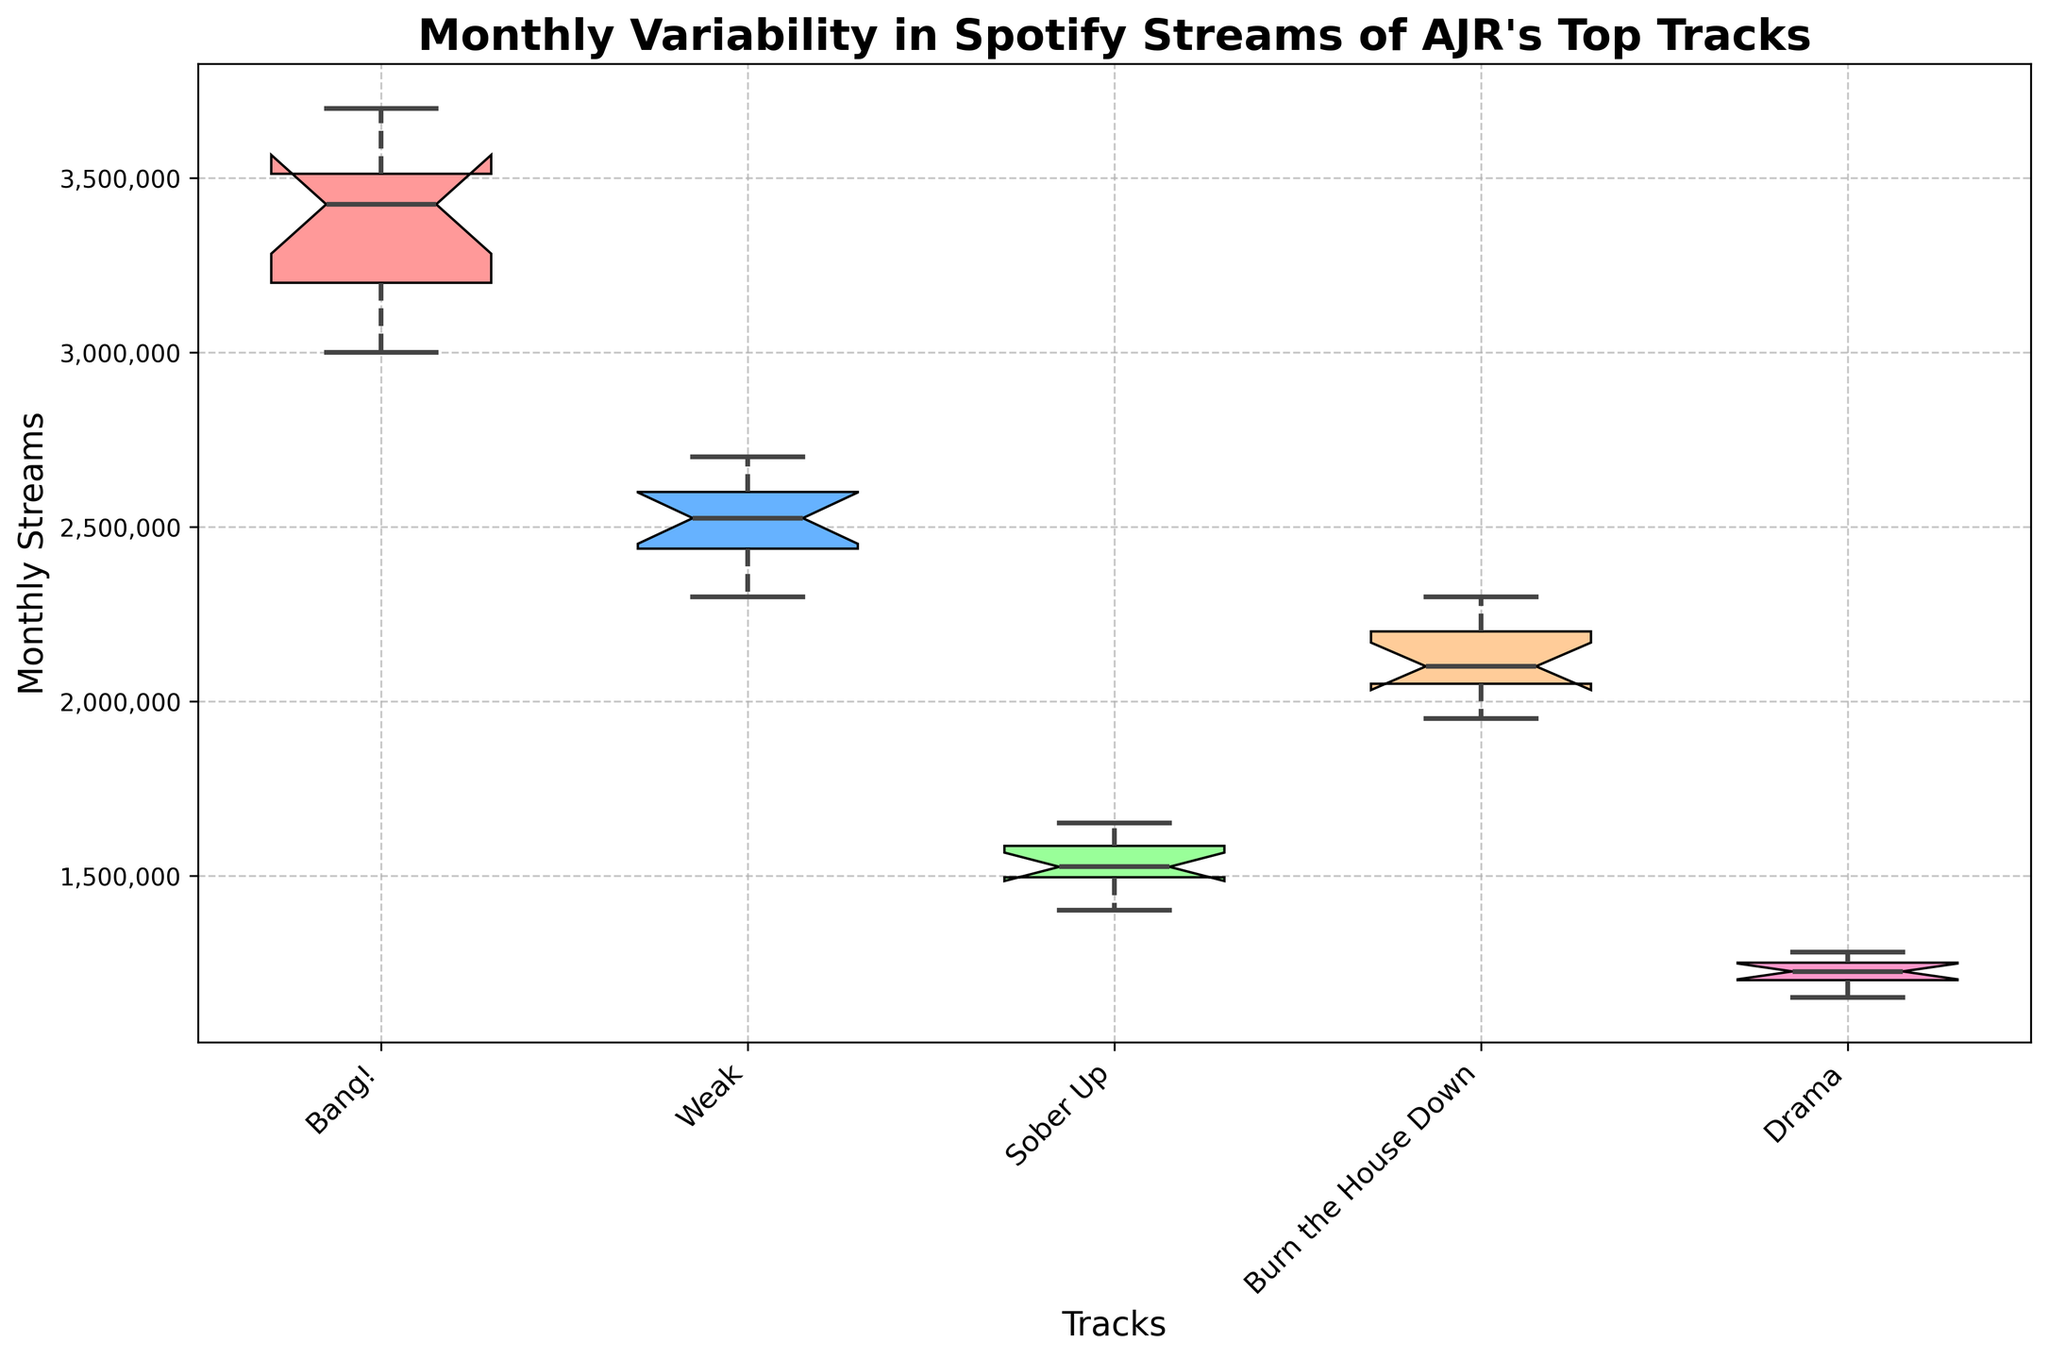What is the title of the plot? The title is located at the top of the plot.
Answer: Monthly Variability in Spotify Streams of AJR's Top Tracks How many tracks are represented in the notched box plot? The x-axis labels list the tracks. Count the unique labels.
Answer: 5 Which track has the highest median monthly streams? Identify the median (middle line) of each track's box plot. Look for the highest median line.
Answer: Bang! Which track shows the least variability in monthly streams? Variability is indicated by the width of the box and the length of the whiskers. The track with the smallest box and shortest whiskers has the least variability.
Answer: Drama Are there any outliers in the data? If yes, for which tracks? Outliers are indicated by individual points outside the whiskers. Identify which tracks have these points.
Answer: No Which track has the widest interquartile range (IQR)? The IQR is the range between the top and bottom of the box. Identify the track with the widest box.
Answer: Weak Compare the maximum monthly streams of "Bang!" and "Sober Up." Which one is higher? Identify the top whisker (maximum value) for both "Bang!" and "Sober Up." Compare their lengths.
Answer: Bang! What is the minimum monthly stream count for "Weak"? Identify the bottom whisker (minimum value) for "Weak."
Answer: 2,300,000 How does the median monthly streams of "Burn the House Down" compare to "Drama"? Identify and compare the median lines of the two tracks.
Answer: Higher What is the approximate range of monthly streams for "Bang!"? The range is the difference between the top and bottom whiskers for "Bang!"
Answer: 3,700,000 - 3,000,000 